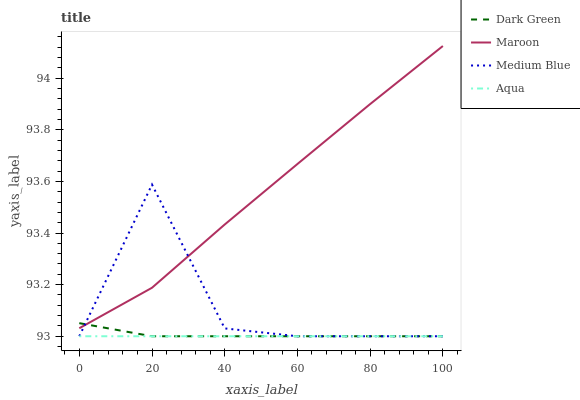Does Medium Blue have the minimum area under the curve?
Answer yes or no. No. Does Medium Blue have the maximum area under the curve?
Answer yes or no. No. Is Maroon the smoothest?
Answer yes or no. No. Is Maroon the roughest?
Answer yes or no. No. Does Maroon have the lowest value?
Answer yes or no. No. Does Medium Blue have the highest value?
Answer yes or no. No. Is Aqua less than Maroon?
Answer yes or no. Yes. Is Maroon greater than Aqua?
Answer yes or no. Yes. Does Aqua intersect Maroon?
Answer yes or no. No. 